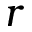<formula> <loc_0><loc_0><loc_500><loc_500>r</formula> 